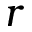<formula> <loc_0><loc_0><loc_500><loc_500>r</formula> 